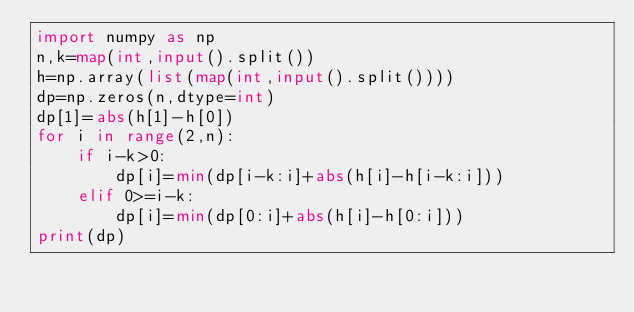<code> <loc_0><loc_0><loc_500><loc_500><_Python_>import numpy as np
n,k=map(int,input().split())
h=np.array(list(map(int,input().split())))
dp=np.zeros(n,dtype=int)
dp[1]=abs(h[1]-h[0])
for i in range(2,n):
    if i-k>0:
        dp[i]=min(dp[i-k:i]+abs(h[i]-h[i-k:i]))
    elif 0>=i-k:
        dp[i]=min(dp[0:i]+abs(h[i]-h[0:i]))
print(dp)</code> 